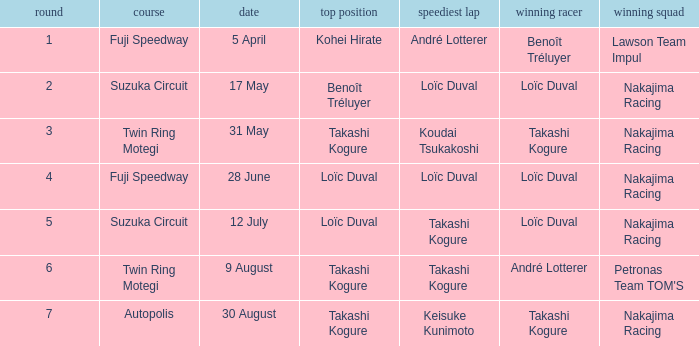How many drivers drove on Suzuka Circuit where Loïc Duval took pole position? 1.0. 